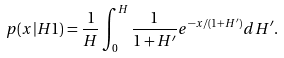Convert formula to latex. <formula><loc_0><loc_0><loc_500><loc_500>p ( x | H 1 ) = \frac { 1 } { H } \int _ { 0 } ^ { H } \frac { 1 } { 1 + H ^ { \prime } } e ^ { - x / ( 1 + H ^ { \prime } ) } d H ^ { \prime } .</formula> 